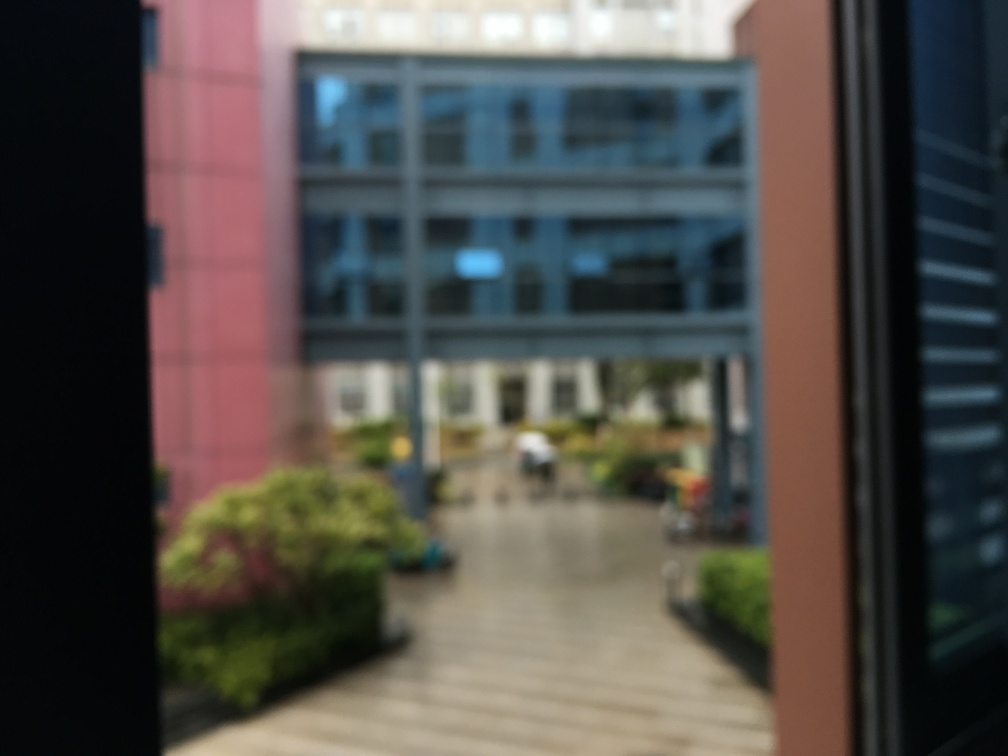Can you tell what this building is used for? While it's challenging to ascertain the specific use due to the blurriness, the building's large windows and structured facade suggest it may be a commercial or office space. 